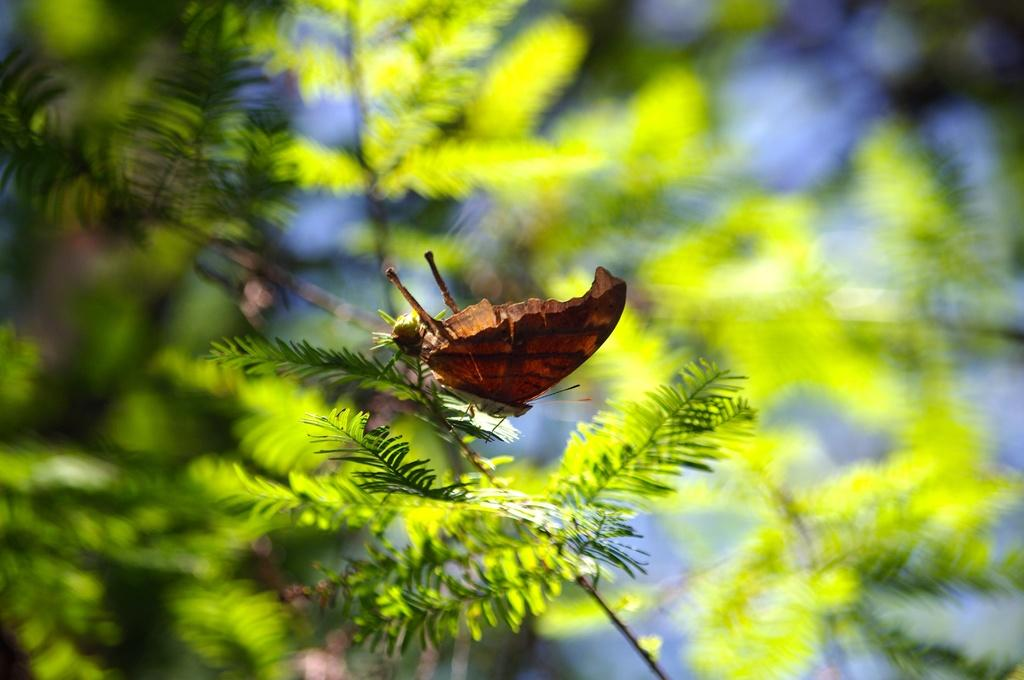What type of vegetation can be seen in the image? There are trees in the image. Can you describe any specific details about the trees? There is a butterfly on one of the trees. What type of authority figure can be seen in the garden in the image? There is no garden or authority figure present in the image; it only features trees and a butterfly. 